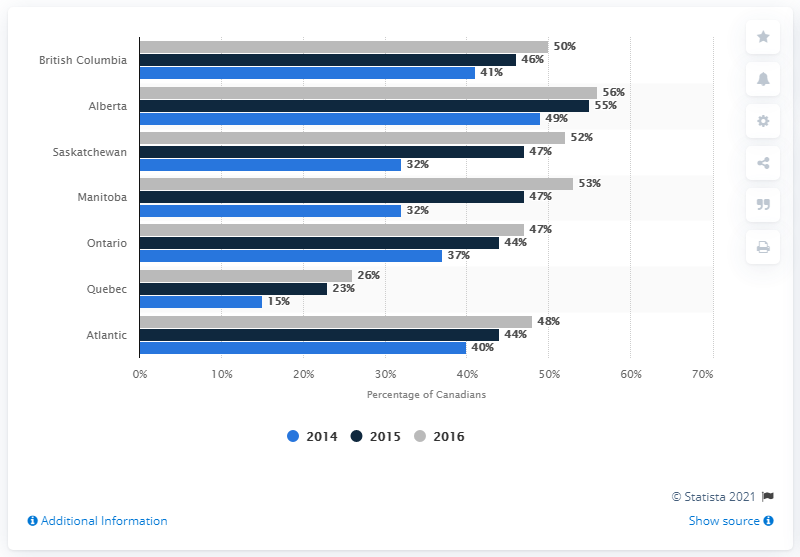Specify some key components in this picture. The second largest share of Netflix subscribers was in the province of Manitoba. According to a report, Alberta had the highest percentage of Netflix subscribers in Canada in 2016. 